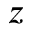<formula> <loc_0><loc_0><loc_500><loc_500>z</formula> 